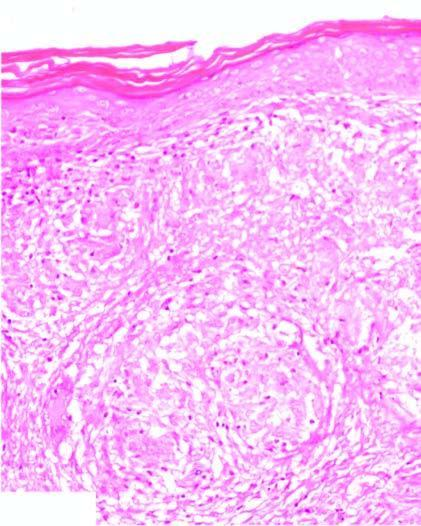does the dermis show noncaseating epithelioid granulomas having langhans ' giant cells and paucity of lymphocytes, termed as naked granulomas?
Answer the question using a single word or phrase. Yes 